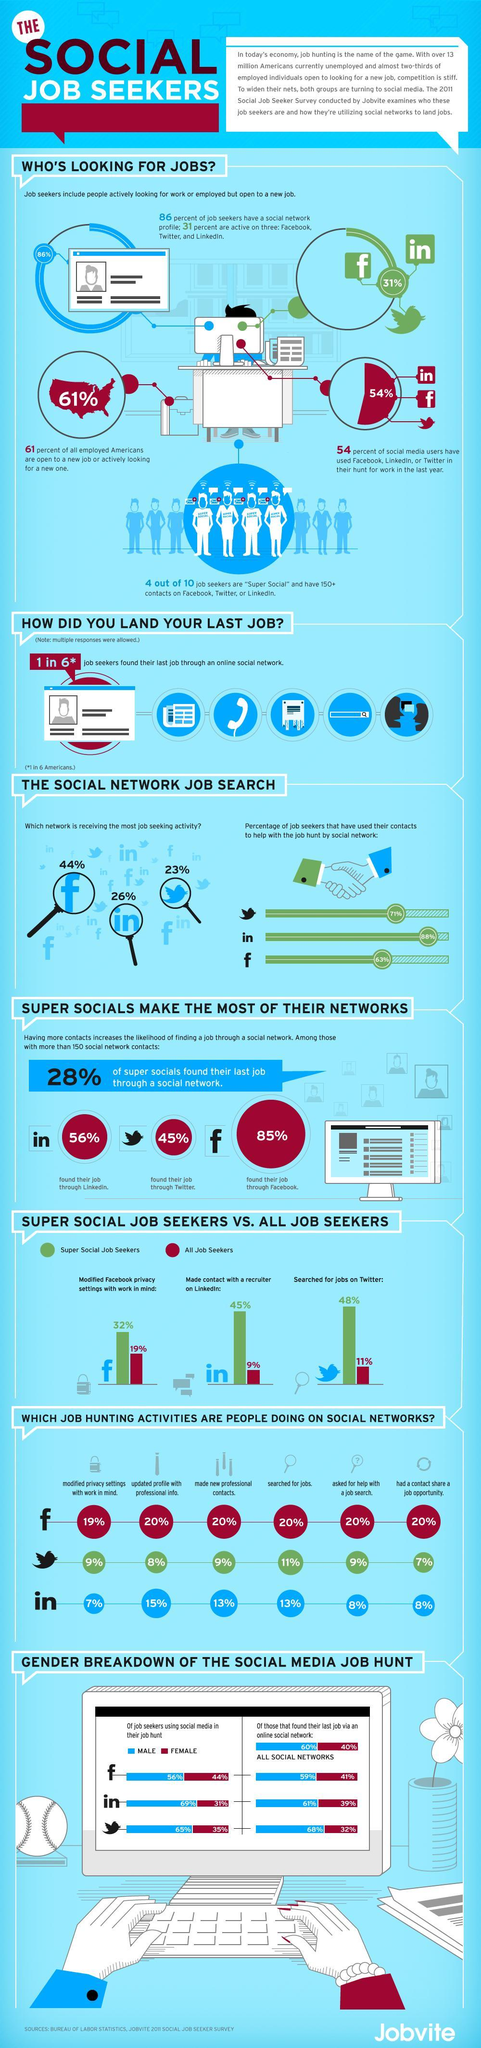What percentage of females found their last job through facebook?
Answer the question with a short phrase. 41% Which network receives the second most job seeking activity? Linkedin Which network receives the least job seeking activity? Twitter How many more people found their job through Facebook than through twitter? 40% What percentage of males are using Linkedin in their job hunt? 69% What percentage of females found their last job through Twitter? 32% How many more people found their job through Facebook than through Linkedin? 29% What percentage of males are using Facebook in their job hunt? 56% 